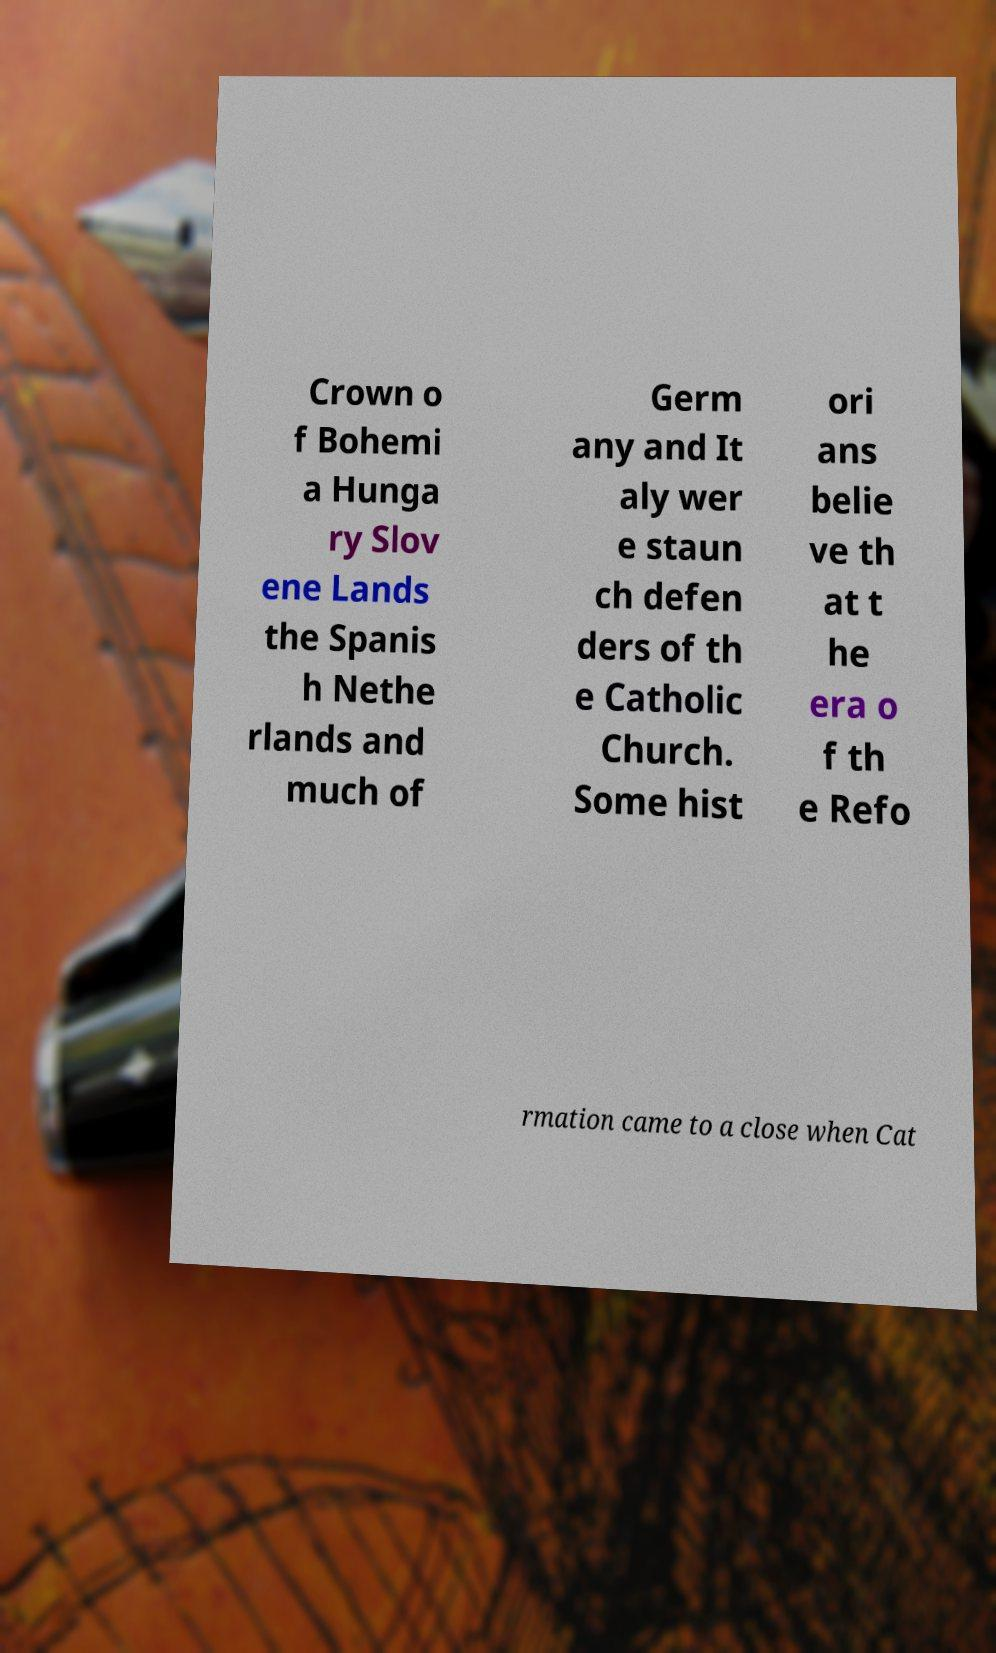There's text embedded in this image that I need extracted. Can you transcribe it verbatim? Crown o f Bohemi a Hunga ry Slov ene Lands the Spanis h Nethe rlands and much of Germ any and It aly wer e staun ch defen ders of th e Catholic Church. Some hist ori ans belie ve th at t he era o f th e Refo rmation came to a close when Cat 